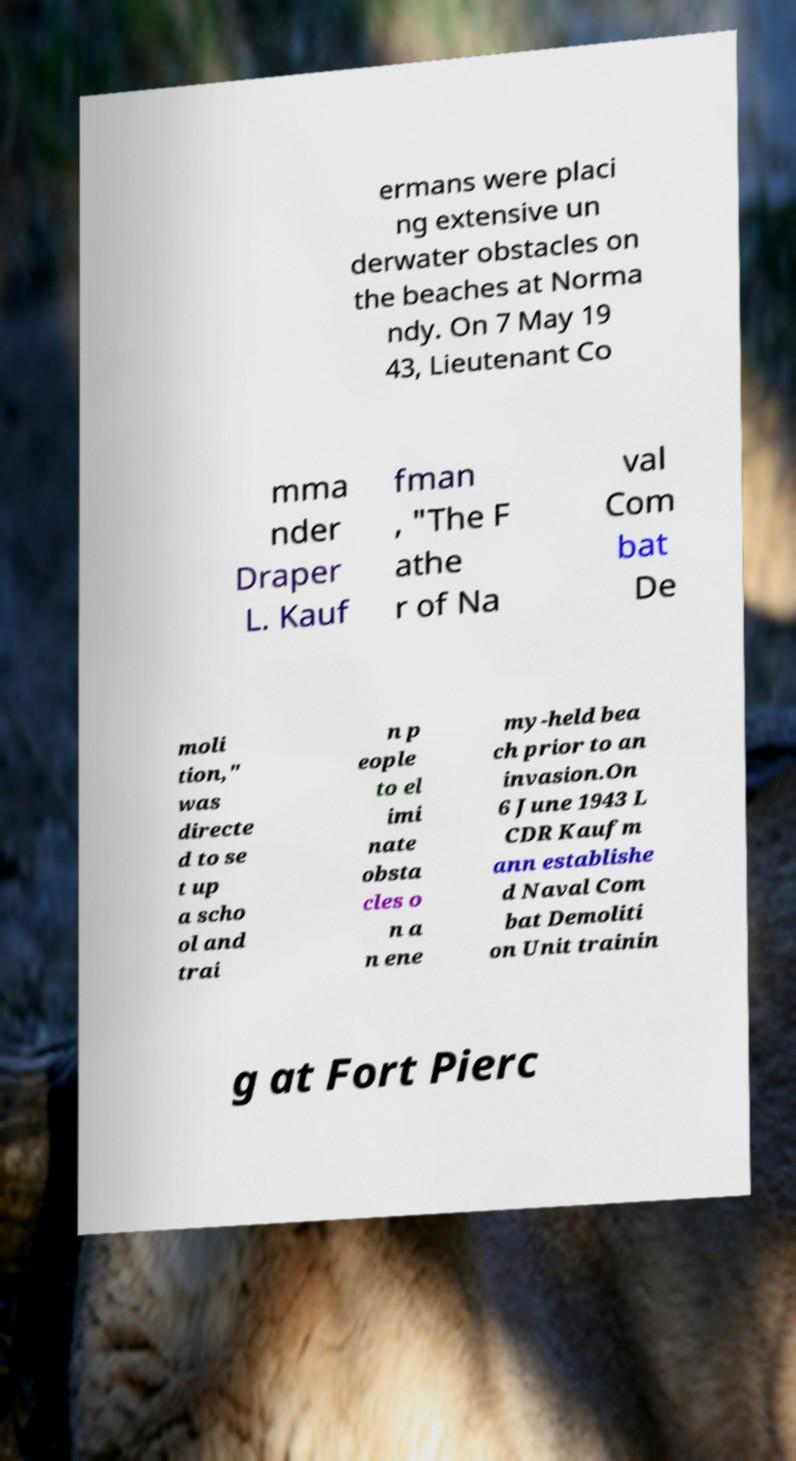Please read and relay the text visible in this image. What does it say? ermans were placi ng extensive un derwater obstacles on the beaches at Norma ndy. On 7 May 19 43, Lieutenant Co mma nder Draper L. Kauf fman , "The F athe r of Na val Com bat De moli tion," was directe d to se t up a scho ol and trai n p eople to el imi nate obsta cles o n a n ene my-held bea ch prior to an invasion.On 6 June 1943 L CDR Kaufm ann establishe d Naval Com bat Demoliti on Unit trainin g at Fort Pierc 